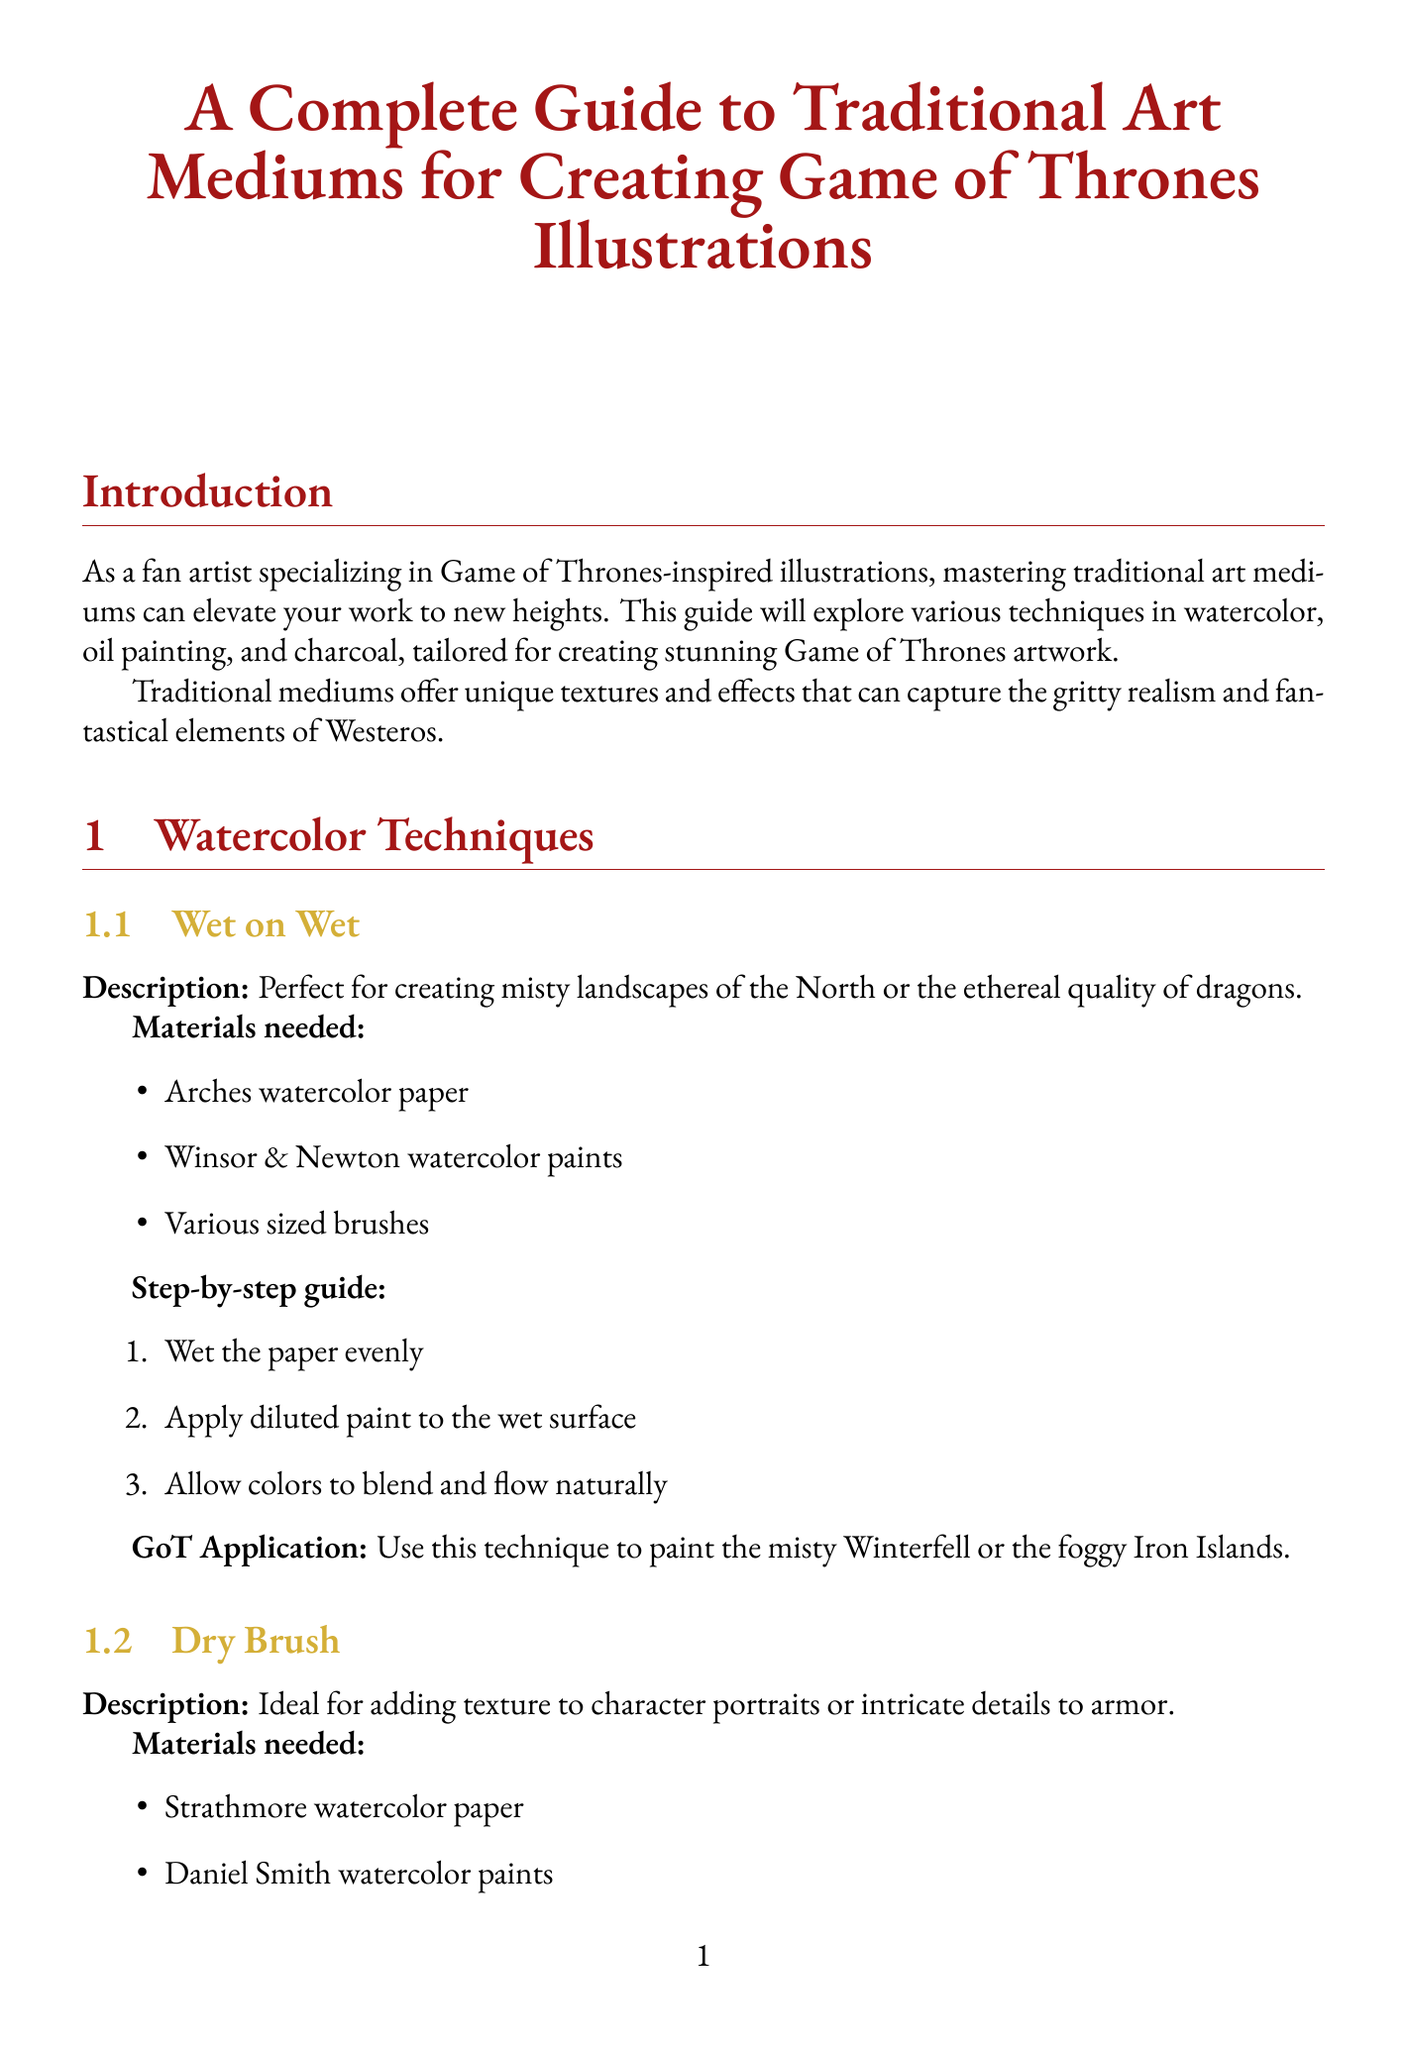What is the recommended medium for painting Nikolaj Coster-Waldau? The document states that oil painting is the recommended medium for detailed skin tones and textures when painting Nikolaj Coster-Waldau.
Answer: Oil painting What are the materials needed for the wet on wet watercolor technique? The wet on wet technique requires Arches watercolor paper, Winsor & Newton watercolor paints, and various sized brushes.
Answer: Arches watercolor paper, Winsor & Newton watercolor paints, various sized brushes Which charcoal technique is ideal for creating smooth gradients and atmospheric effects? According to the guide, the blending technique is highlighted for creating smooth gradients and atmospheric effects.
Answer: Blending What color represents the heading for the oil painting techniques section? The document uses the specified color formatting rules, showing that the heading for oil painting techniques is in a specific color.
Answer: Gold What is one of the key features of Nikolaj Coster-Waldau? The guide lists several key features, one of which is a strong jawline.
Answer: Strong jawline How many steps are provided in the step-by-step guide for the dry brush technique? The dry brush technique includes three specific steps in its guide.
Answer: Three What effect does the impasto technique create? The impasto technique is described as creating bold, textured strokes ideal for dramatic Game of Thrones scenes.
Answer: Bold, textured strokes What is the GoT application of the hatching and cross-hatching technique? The application states that this technique is excellent for detailing intricate costumes or creating texture in landscapes like the Red Keep.
Answer: Detailing intricate costumes or creating texture in landscapes like the Red Keep What is the purpose of traditional art mediums in fan art? The introduction outlines that traditional mediums offer unique textures and effects to capture themes in fan art.
Answer: Capture gritty realism and fantastical elements 